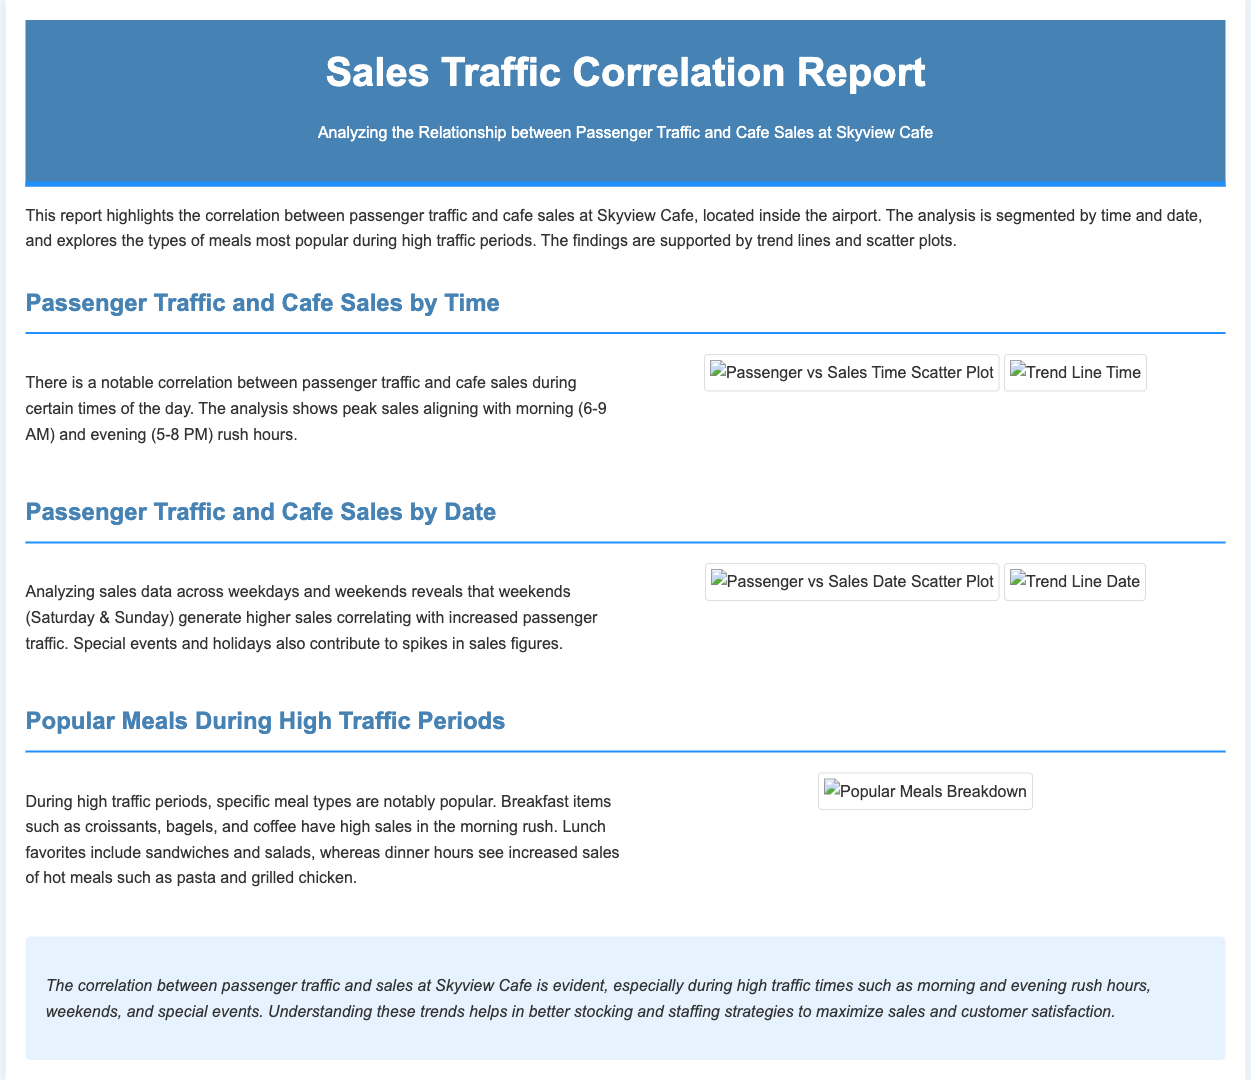What are the peak sales hours? The document states that peak sales are aligned with the morning (6-9 AM) and evening (5-8 PM) rush hours.
Answer: Morning and evening What days generate higher sales? The report mentions that weekends, specifically Saturday and Sunday, generate higher sales correlating with increased passenger traffic.
Answer: Weekends Which meal type is popular during morning rush? The report identifies breakfast items such as croissants, bagels, and coffee as being popular during morning rush hours.
Answer: Breakfast items What is the title of the report? The report is titled "Sales Traffic Correlation Report - Skyview Cafe."
Answer: Sales Traffic Correlation Report What time segments are analyzed for sales correlation? The document analyzes sales correlation by time of day and by date (weekdays and weekends).
Answer: Time of day and date What types of meals are popular for lunch? According to the analysis, lunch favorites include sandwiches and salads during high traffic periods.
Answer: Sandwiches and salads What contributes to spikes in sales figures? The report mentions that special events and holidays contribute to spikes in sales figures.
Answer: Special events and holidays What visual aids are used in the document? The report includes scatter plots and trend lines to support the analysis of passenger traffic and cafe sales.
Answer: Scatter plots and trend lines 